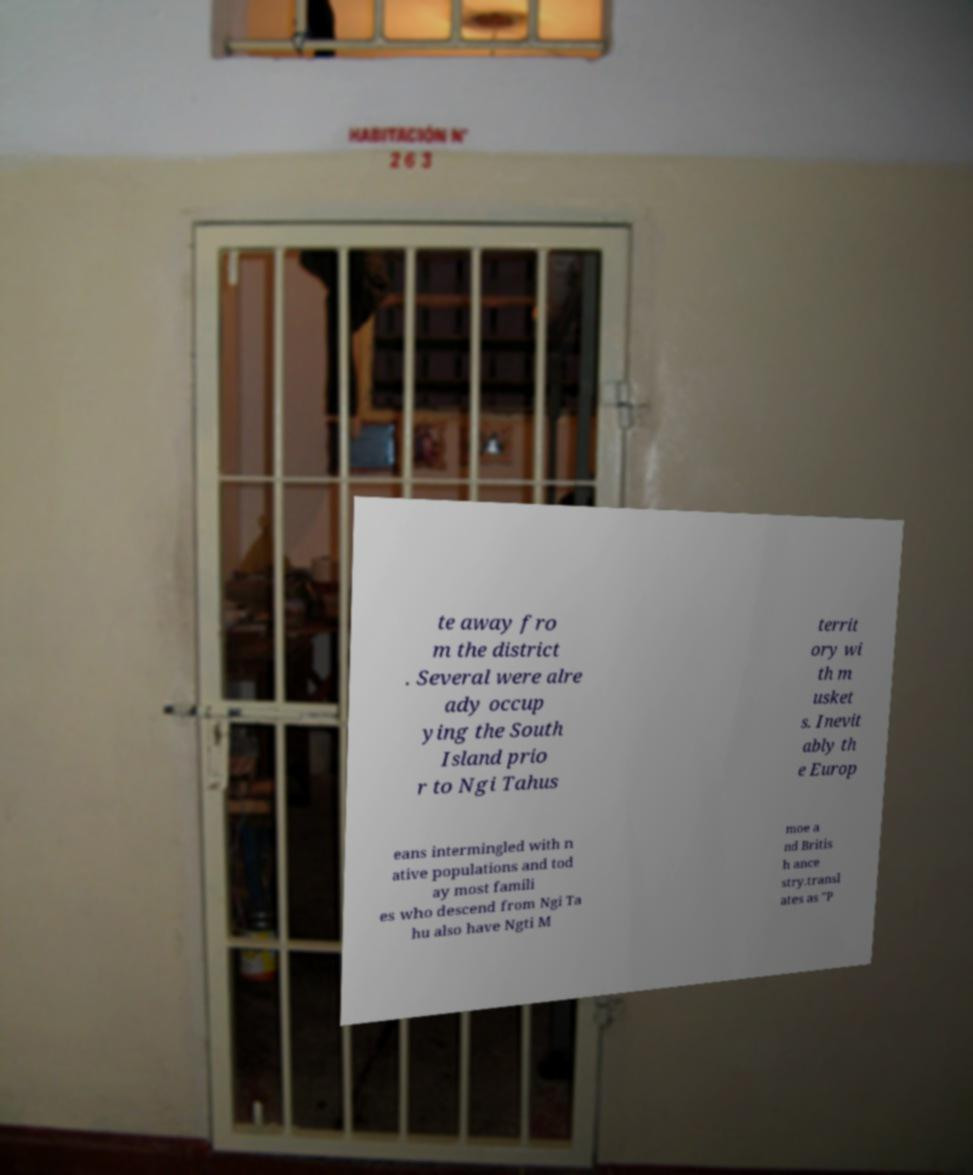Could you extract and type out the text from this image? te away fro m the district . Several were alre ady occup ying the South Island prio r to Ngi Tahus territ ory wi th m usket s. Inevit ably th e Europ eans intermingled with n ative populations and tod ay most famili es who descend from Ngi Ta hu also have Ngti M moe a nd Britis h ance stry.transl ates as "P 